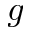Convert formula to latex. <formula><loc_0><loc_0><loc_500><loc_500>g</formula> 